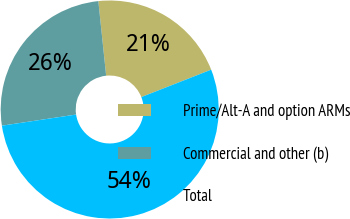Convert chart. <chart><loc_0><loc_0><loc_500><loc_500><pie_chart><fcel>Prime/Alt-A and option ARMs<fcel>Commercial and other (b)<fcel>Total<nl><fcel>20.71%<fcel>25.71%<fcel>53.58%<nl></chart> 